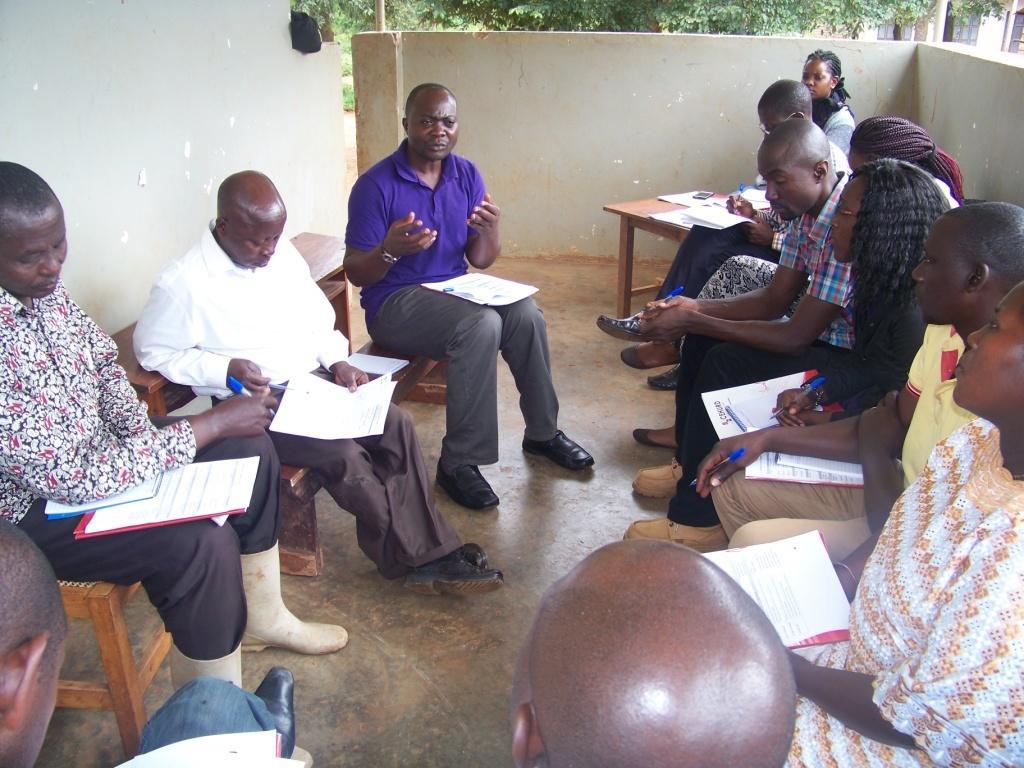In one or two sentences, can you explain what this image depicts? In this image there are group of people who are discussing between them by sitting on the bench. Everyone is holding the paper in their hands. At the background there is a wall and trees above it. 